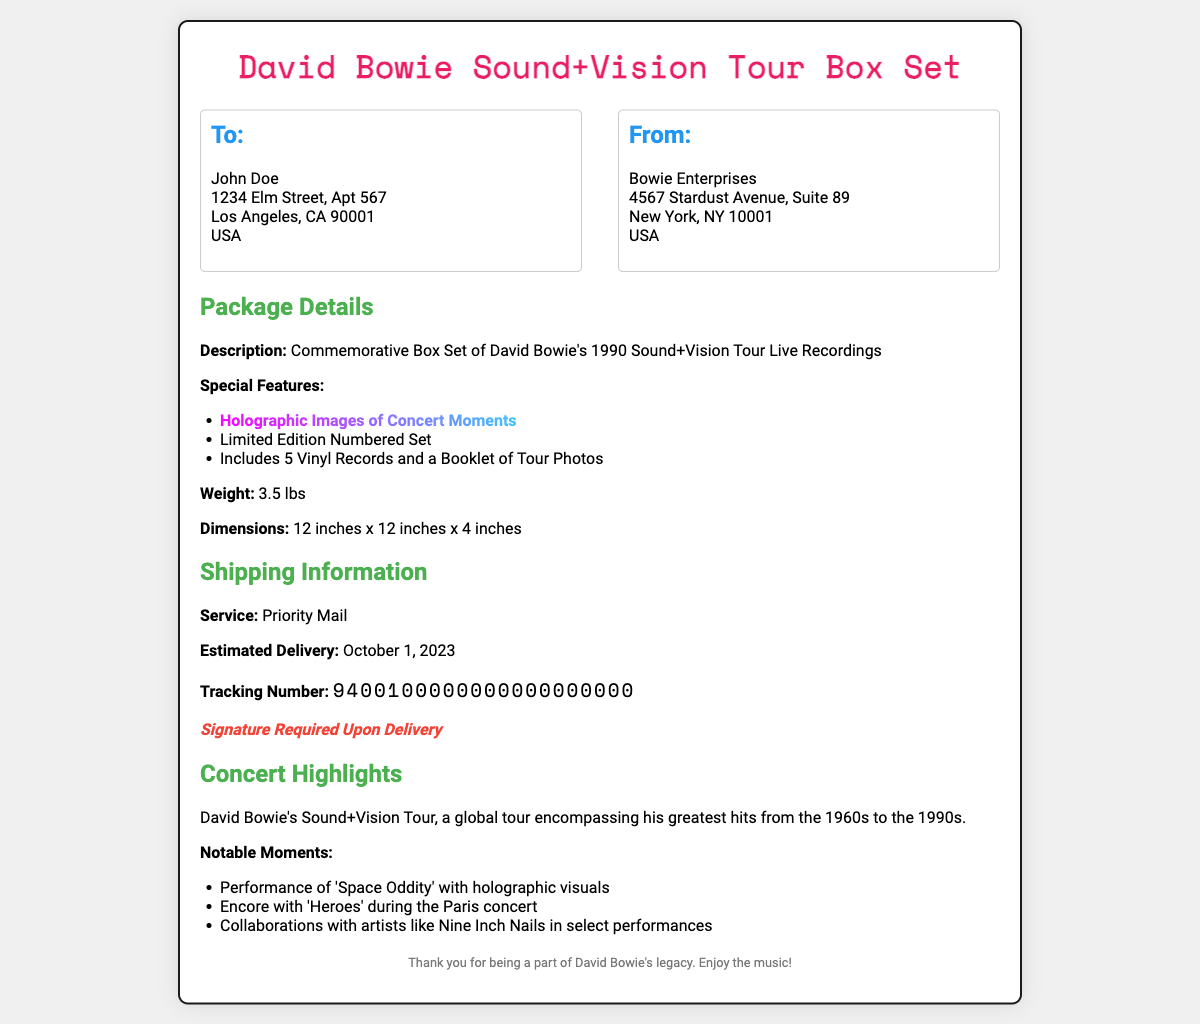What is the weight of the box set? The weight of the box set is specifically mentioned in the package details section.
Answer: 3.5 lbs Who is the recipient of the box set? The document specifies the name and address of the recipient in the 'To:' section.
Answer: John Doe What is included in the box set? The package details indicate the contents, including the number of vinyl records and booklet.
Answer: 5 Vinyl Records and a Booklet of Tour Photos What type of shipping service is used? The shipping information section provides details about the service used for shipping.
Answer: Priority Mail What is the estimated delivery date? The shipping information includes the specific date for estimated delivery of the package.
Answer: October 1, 2023 What notable song was performed during the encore? The concert details highlight a specific notable moment during the performance.
Answer: Heroes What special feature highlights the concert moments? The package details mention a particular feature that enhances the visual experience of the concert recordings.
Answer: Holographic Images of Concert Moments What is the return address for the package? The 'From:' section of the document outlines the return address for the shipment.
Answer: Bowie Enterprises, 4567 Stardust Avenue, Suite 89, New York, NY 10001, USA What does the signature requirement mean? The shipping information mentions the need for a signature, indicating delivery confirmation on reception.
Answer: Signature Required Upon Delivery 